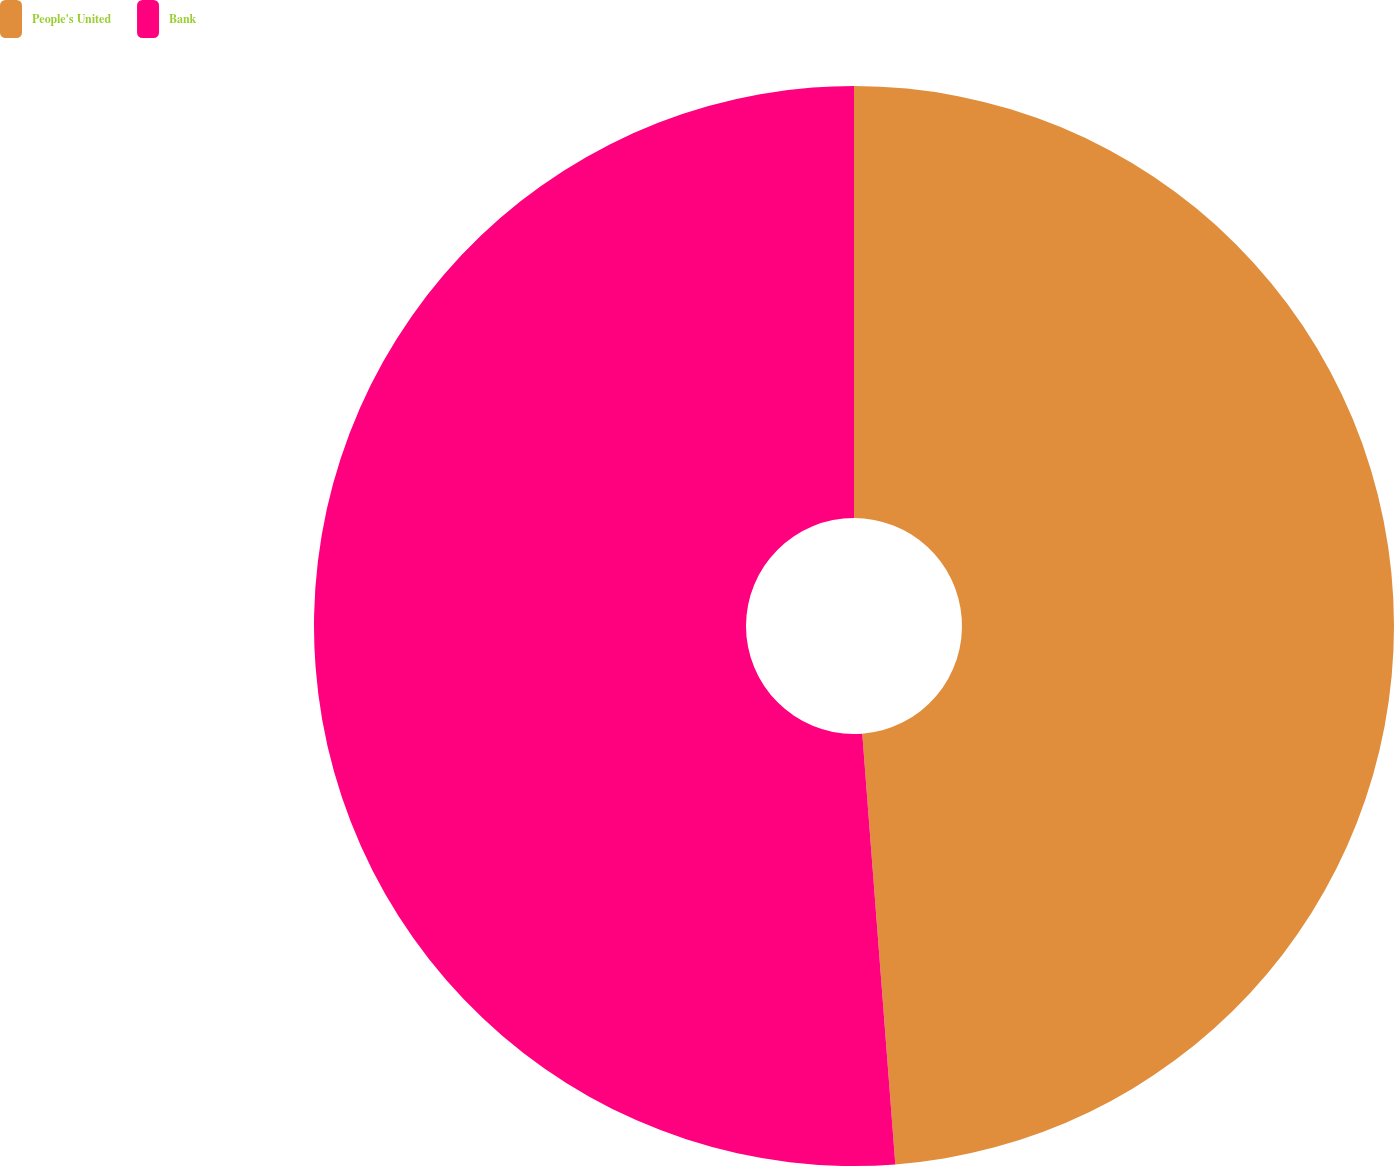Convert chart. <chart><loc_0><loc_0><loc_500><loc_500><pie_chart><fcel>People's United<fcel>Bank<nl><fcel>48.78%<fcel>51.22%<nl></chart> 